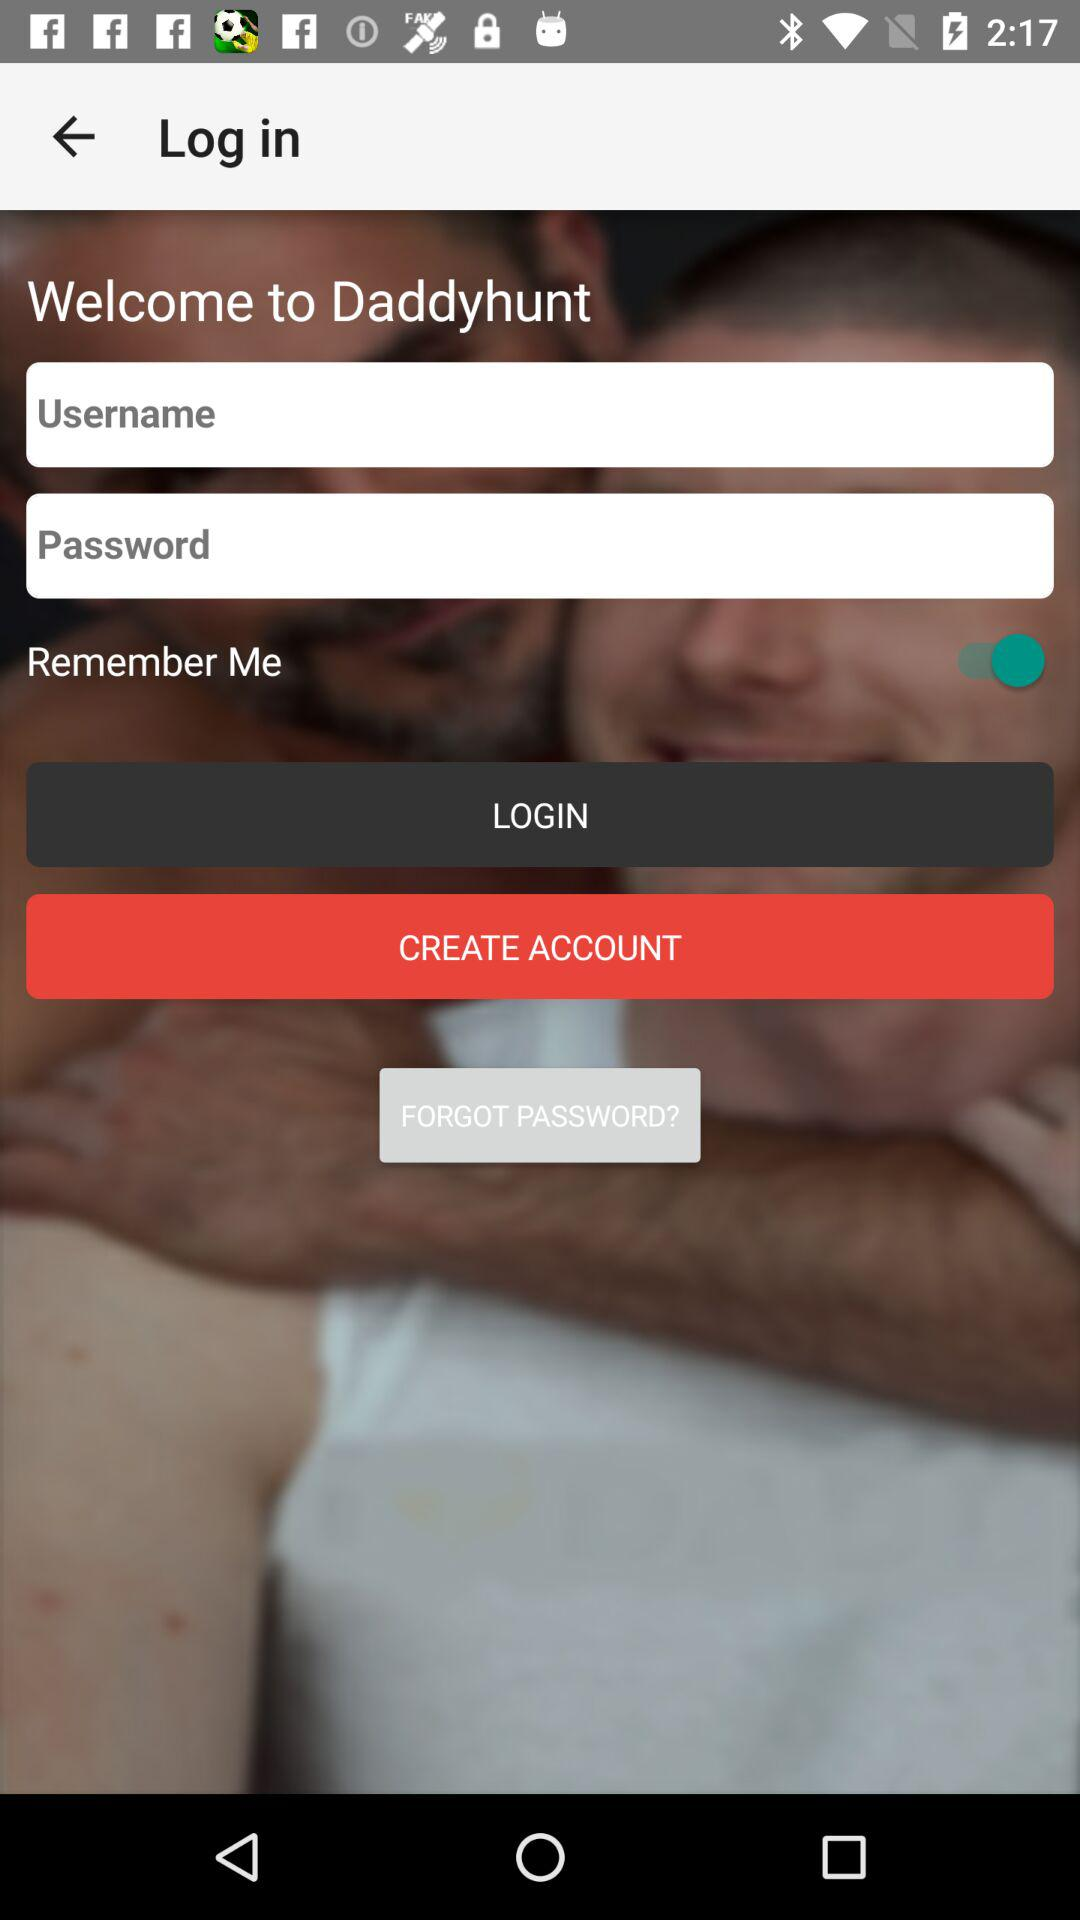What is the status of "Remember Me"? The status is "on". 